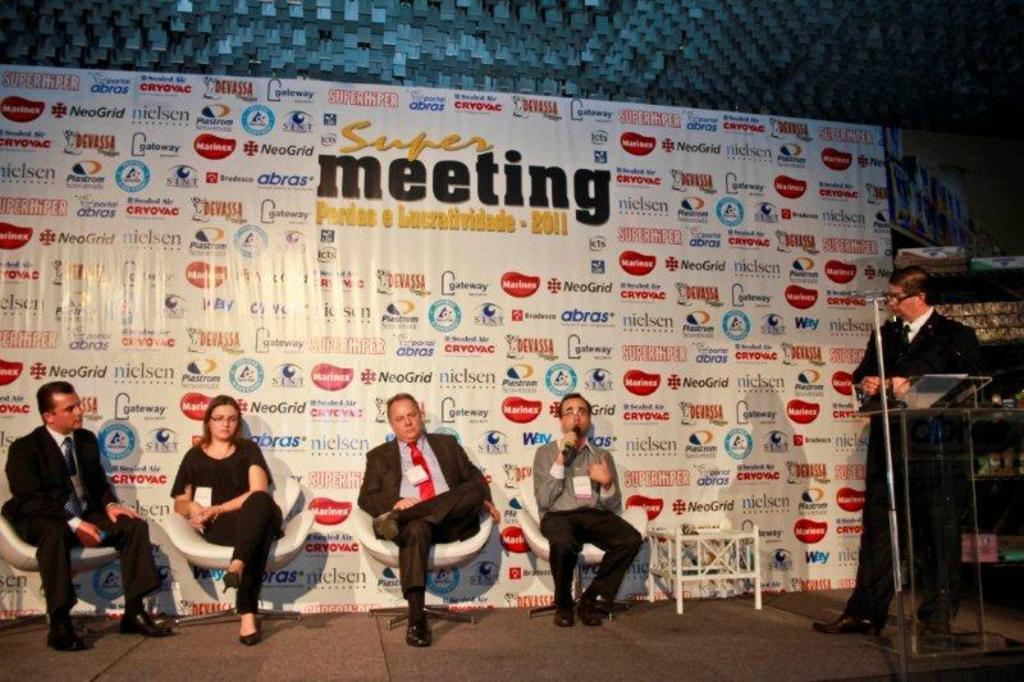What is the man in the image doing? The man is standing behind a podium. How many people are sitting on chairs on the left side of the man? There are four people sitting on chairs on the left side of the man. What can be seen behind the people? There is a board visible behind the people. What color crayon is the man using to draw on the board? There is no crayon present in the image. 